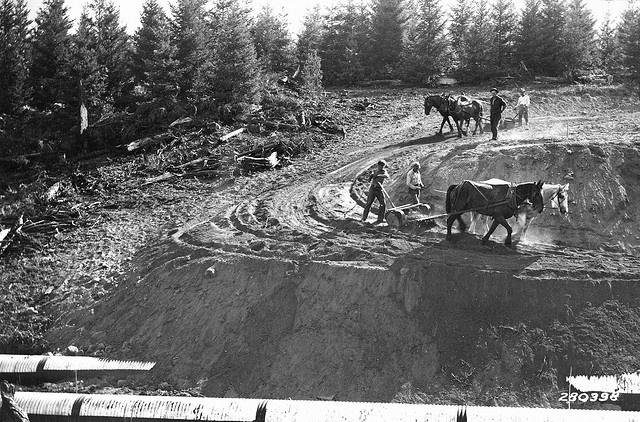Describe the objects in this image and their specific colors. I can see horse in lightgray, black, gray, and darkgray tones, people in lightgray, black, gray, and darkgray tones, horse in lightgray, gray, darkgray, and black tones, horse in lightgray, black, gray, and darkgray tones, and people in lightgray, black, gray, darkgray, and gainsboro tones in this image. 